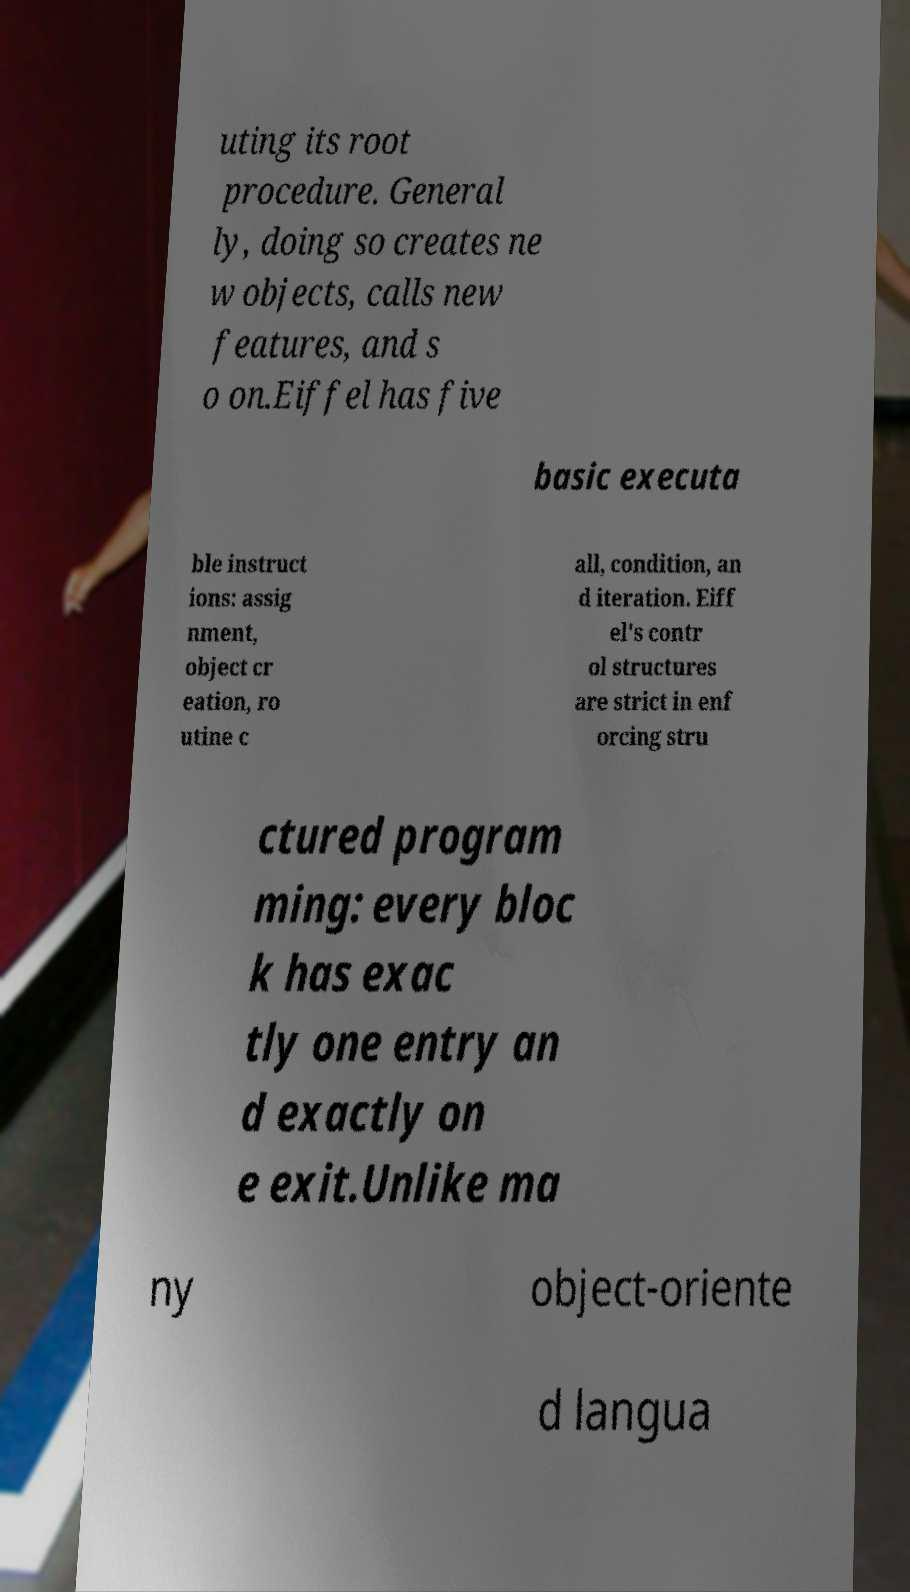Could you assist in decoding the text presented in this image and type it out clearly? uting its root procedure. General ly, doing so creates ne w objects, calls new features, and s o on.Eiffel has five basic executa ble instruct ions: assig nment, object cr eation, ro utine c all, condition, an d iteration. Eiff el's contr ol structures are strict in enf orcing stru ctured program ming: every bloc k has exac tly one entry an d exactly on e exit.Unlike ma ny object-oriente d langua 